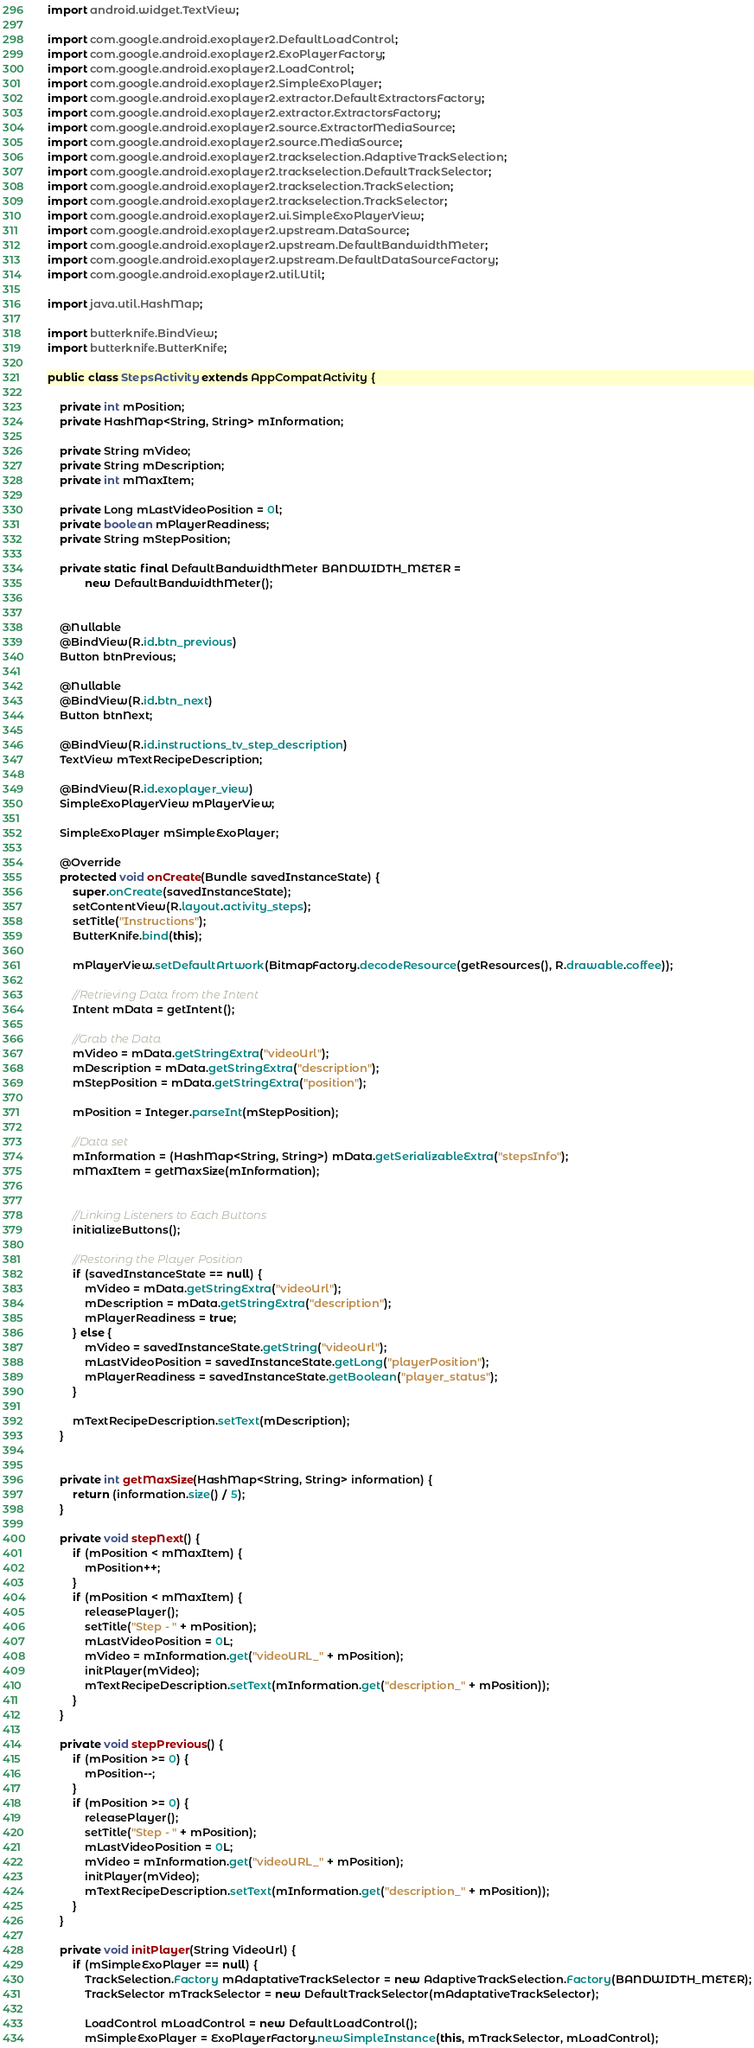<code> <loc_0><loc_0><loc_500><loc_500><_Java_>import android.widget.TextView;

import com.google.android.exoplayer2.DefaultLoadControl;
import com.google.android.exoplayer2.ExoPlayerFactory;
import com.google.android.exoplayer2.LoadControl;
import com.google.android.exoplayer2.SimpleExoPlayer;
import com.google.android.exoplayer2.extractor.DefaultExtractorsFactory;
import com.google.android.exoplayer2.extractor.ExtractorsFactory;
import com.google.android.exoplayer2.source.ExtractorMediaSource;
import com.google.android.exoplayer2.source.MediaSource;
import com.google.android.exoplayer2.trackselection.AdaptiveTrackSelection;
import com.google.android.exoplayer2.trackselection.DefaultTrackSelector;
import com.google.android.exoplayer2.trackselection.TrackSelection;
import com.google.android.exoplayer2.trackselection.TrackSelector;
import com.google.android.exoplayer2.ui.SimpleExoPlayerView;
import com.google.android.exoplayer2.upstream.DataSource;
import com.google.android.exoplayer2.upstream.DefaultBandwidthMeter;
import com.google.android.exoplayer2.upstream.DefaultDataSourceFactory;
import com.google.android.exoplayer2.util.Util;

import java.util.HashMap;

import butterknife.BindView;
import butterknife.ButterKnife;

public class StepsActivity extends AppCompatActivity {

    private int mPosition;
    private HashMap<String, String> mInformation;

    private String mVideo;
    private String mDescription;
    private int mMaxItem;

    private Long mLastVideoPosition = 0l;
    private boolean mPlayerReadiness;
    private String mStepPosition;

    private static final DefaultBandwidthMeter BANDWIDTH_METER =
            new DefaultBandwidthMeter();


    @Nullable
    @BindView(R.id.btn_previous)
    Button btnPrevious;

    @Nullable
    @BindView(R.id.btn_next)
    Button btnNext;

    @BindView(R.id.instructions_tv_step_description)
    TextView mTextRecipeDescription;

    @BindView(R.id.exoplayer_view)
    SimpleExoPlayerView mPlayerView;

    SimpleExoPlayer mSimpleExoPlayer;

    @Override
    protected void onCreate(Bundle savedInstanceState) {
        super.onCreate(savedInstanceState);
        setContentView(R.layout.activity_steps);
        setTitle("Instructions");
        ButterKnife.bind(this);

        mPlayerView.setDefaultArtwork(BitmapFactory.decodeResource(getResources(), R.drawable.coffee));

        //Retrieving Data from the Intent
        Intent mData = getIntent();

        //Grab the Data
        mVideo = mData.getStringExtra("videoUrl");
        mDescription = mData.getStringExtra("description");
        mStepPosition = mData.getStringExtra("position");

        mPosition = Integer.parseInt(mStepPosition);

        //Data set
        mInformation = (HashMap<String, String>) mData.getSerializableExtra("stepsInfo");
        mMaxItem = getMaxSize(mInformation);


        //Linking Listeners to Each Buttons
        initializeButtons();

        //Restoring the Player Position
        if (savedInstanceState == null) {
            mVideo = mData.getStringExtra("videoUrl");
            mDescription = mData.getStringExtra("description");
            mPlayerReadiness = true;
        } else {
            mVideo = savedInstanceState.getString("videoUrl");
            mLastVideoPosition = savedInstanceState.getLong("playerPosition");
            mPlayerReadiness = savedInstanceState.getBoolean("player_status");
        }

        mTextRecipeDescription.setText(mDescription);
    }


    private int getMaxSize(HashMap<String, String> information) {
        return (information.size() / 5);
    }

    private void stepNext() {
        if (mPosition < mMaxItem) {
            mPosition++;
        }
        if (mPosition < mMaxItem) {
            releasePlayer();
            setTitle("Step - " + mPosition);
            mLastVideoPosition = 0L;
            mVideo = mInformation.get("videoURL_" + mPosition);
            initPlayer(mVideo);
            mTextRecipeDescription.setText(mInformation.get("description_" + mPosition));
        }
    }

    private void stepPrevious() {
        if (mPosition >= 0) {
            mPosition--;
        }
        if (mPosition >= 0) {
            releasePlayer();
            setTitle("Step - " + mPosition);
            mLastVideoPosition = 0L;
            mVideo = mInformation.get("videoURL_" + mPosition);
            initPlayer(mVideo);
            mTextRecipeDescription.setText(mInformation.get("description_" + mPosition));
        }
    }

    private void initPlayer(String VideoUrl) {
        if (mSimpleExoPlayer == null) {
            TrackSelection.Factory mAdaptativeTrackSelector = new AdaptiveTrackSelection.Factory(BANDWIDTH_METER);
            TrackSelector mTrackSelector = new DefaultTrackSelector(mAdaptativeTrackSelector);

            LoadControl mLoadControl = new DefaultLoadControl();
            mSimpleExoPlayer = ExoPlayerFactory.newSimpleInstance(this, mTrackSelector, mLoadControl);</code> 